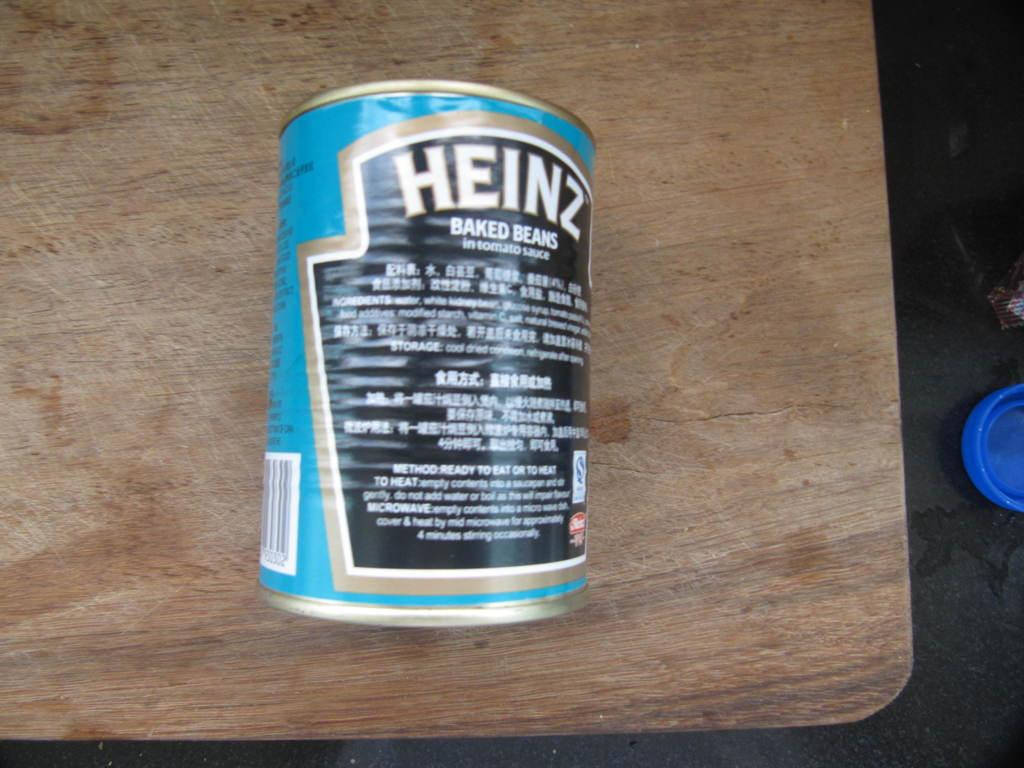<image>
Provide a brief description of the given image. The back of a blue Heinz branded baked beans. 